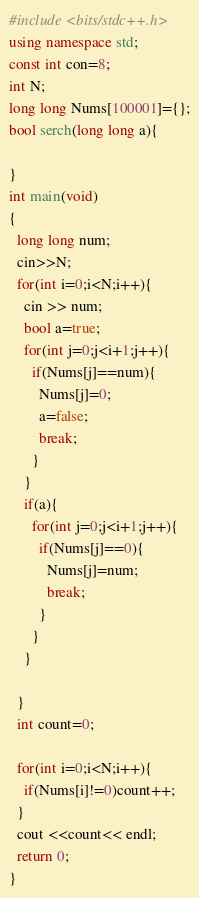Convert code to text. <code><loc_0><loc_0><loc_500><loc_500><_C++_>#include <bits/stdc++.h>
using namespace std;
const int con=8;
int N;
long long Nums[100001]={};
bool serch(long long a){
   
}
int main(void)
{
  long long num;
  cin>>N;
  for(int i=0;i<N;i++){
    cin >> num;
    bool a=true;
    for(int j=0;j<i+1;j++){
      if(Nums[j]==num){
        Nums[j]=0;
        a=false;
        break;
      }
    }
    if(a){
      for(int j=0;j<i+1;j++){
        if(Nums[j]==0){
          Nums[j]=num;
          break;
        }
      }
    }
    
  }
  int count=0;
  
  for(int i=0;i<N;i++){
    if(Nums[i]!=0)count++;
  }
  cout <<count<< endl;
  return 0;
}</code> 